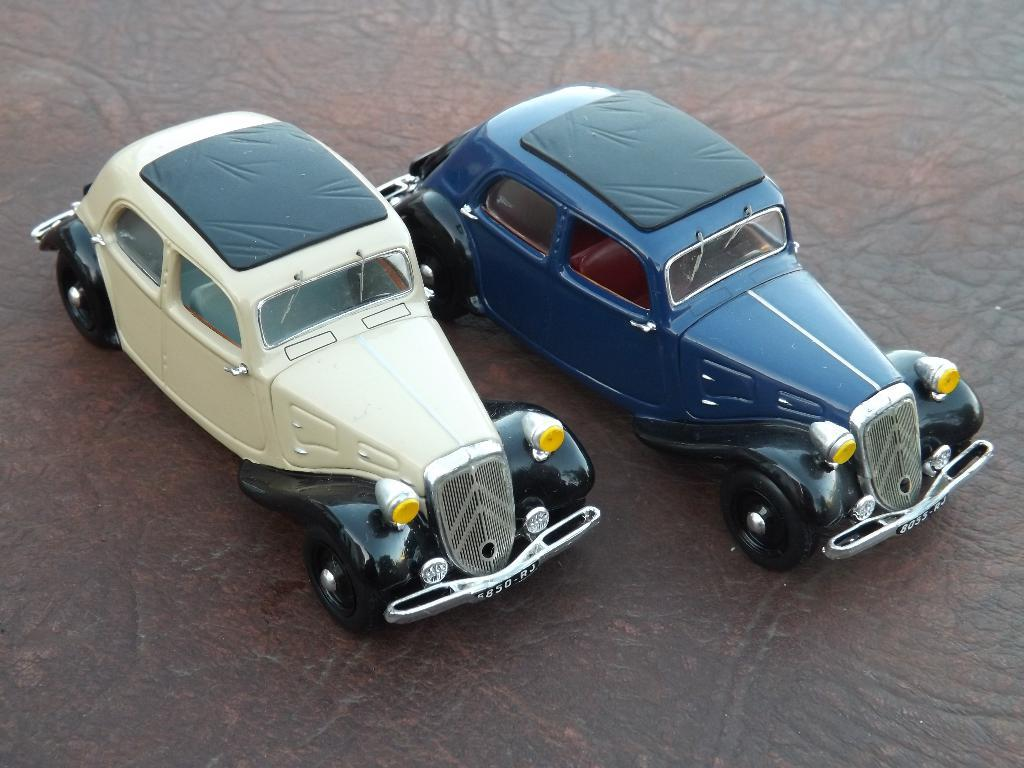What type of vehicles are present in the image? There are cars in the image. Where are the cars located in the image? The cars are placed on a table. Is there a river flowing under the bridge in the image? There is no river or bridge present in the image; it only features cars placed on a table. 